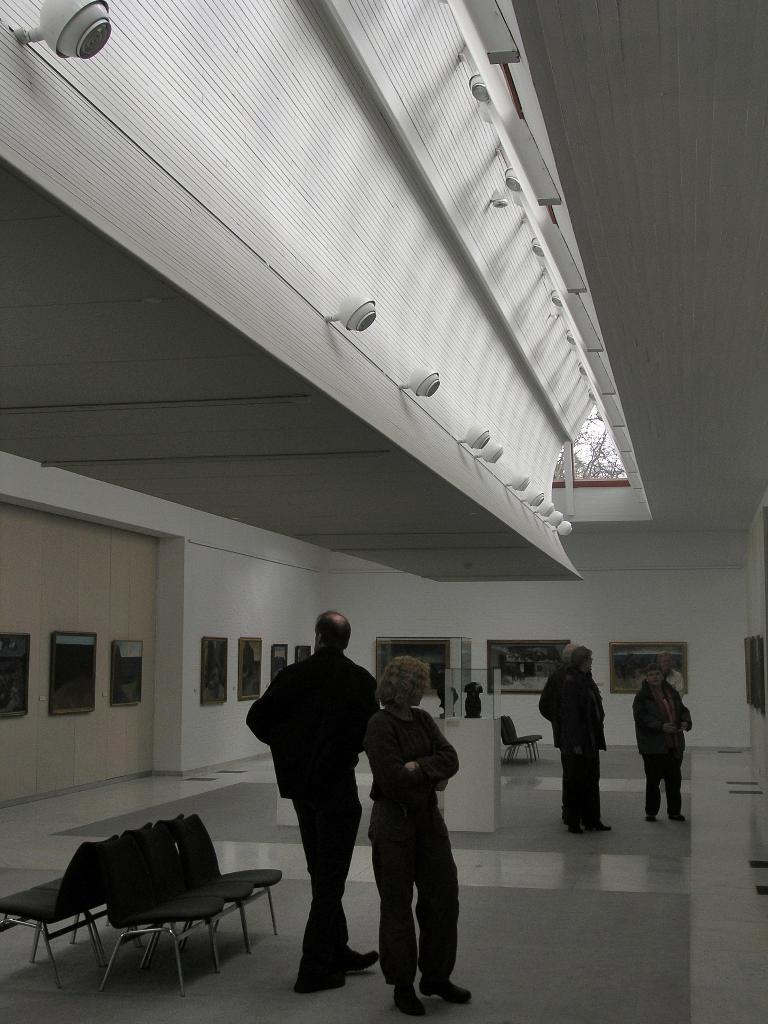Who or what is present in the image? There are people in the image. What objects are in the image that people might sit on? There are chairs in the image. What can be seen on the walls in the image? There are frames placed on the walls. What is visible at the top of the image? There are lights at the top of the image. What type of rice is being served in the image? There is no rice present in the image. Is there a judge presiding over the people in the image? There is no judge present in the image. 